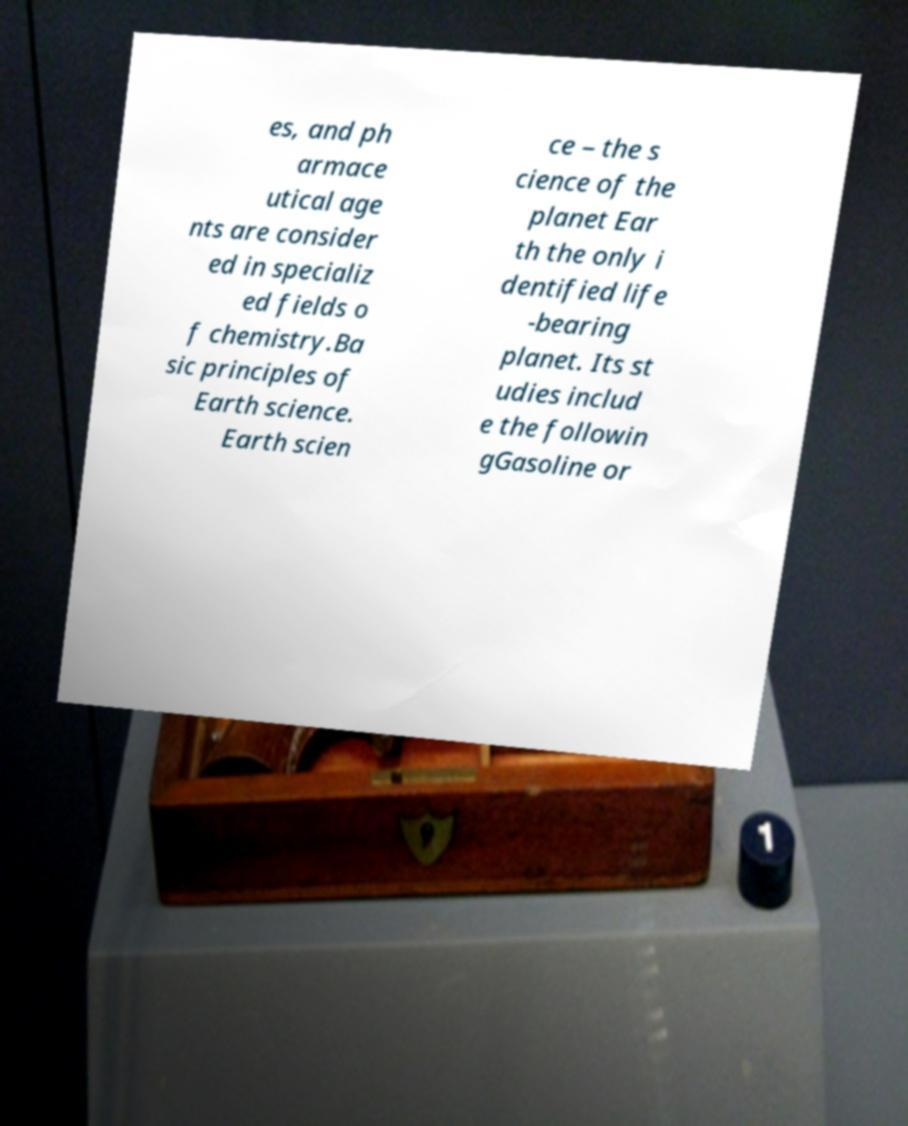Please read and relay the text visible in this image. What does it say? es, and ph armace utical age nts are consider ed in specializ ed fields o f chemistry.Ba sic principles of Earth science. Earth scien ce – the s cience of the planet Ear th the only i dentified life -bearing planet. Its st udies includ e the followin gGasoline or 